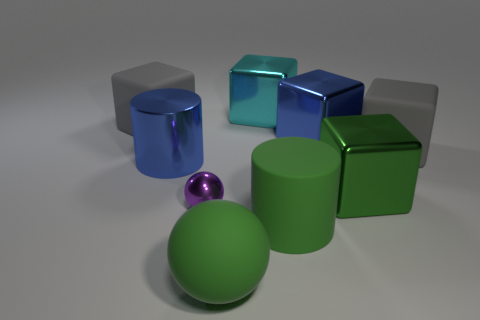Subtract all large blue metallic cubes. How many cubes are left? 4 Subtract all yellow cylinders. How many gray cubes are left? 2 Add 1 green objects. How many objects exist? 10 Subtract all green blocks. How many blocks are left? 4 Subtract all cubes. How many objects are left? 4 Add 3 big green rubber objects. How many big green rubber objects are left? 5 Add 5 purple metal spheres. How many purple metal spheres exist? 6 Subtract 0 yellow balls. How many objects are left? 9 Subtract all purple cubes. Subtract all red balls. How many cubes are left? 5 Subtract all green things. Subtract all tiny purple shiny spheres. How many objects are left? 5 